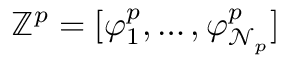<formula> <loc_0><loc_0><loc_500><loc_500>\mathbb { Z } ^ { p } = [ \varphi _ { 1 } ^ { p } , \dots , \varphi _ { \mathcal { N } _ { p } } ^ { p } ]</formula> 